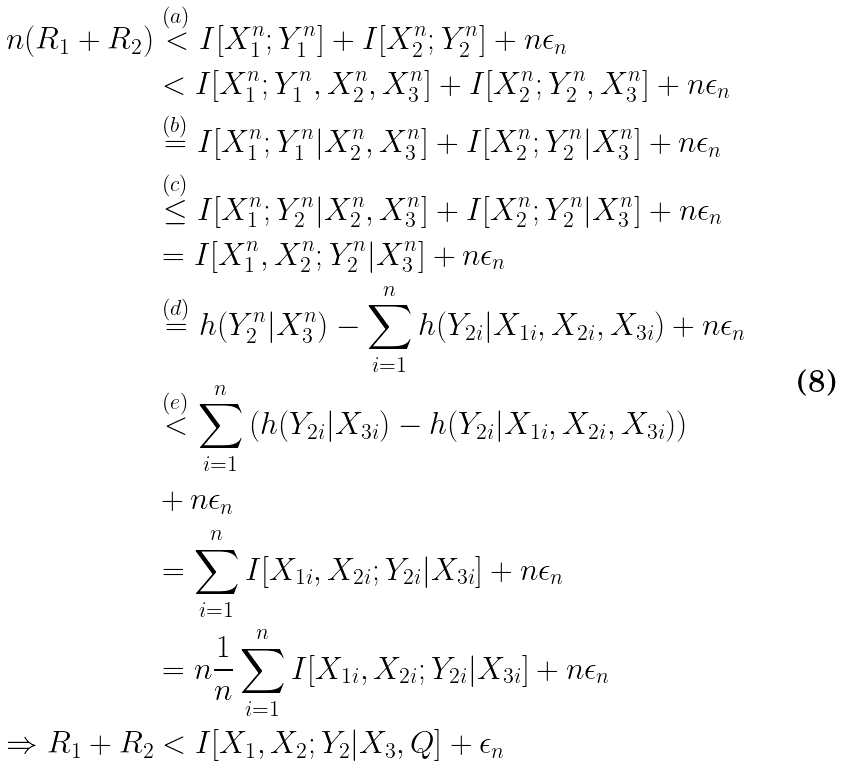Convert formula to latex. <formula><loc_0><loc_0><loc_500><loc_500>n ( R _ { 1 } + R _ { 2 } ) & \stackrel { ( a ) } { < } I [ X _ { 1 } ^ { n } ; Y _ { 1 } ^ { n } ] + I [ X _ { 2 } ^ { n } ; Y _ { 2 } ^ { n } ] + n \epsilon _ { n } \\ & < I [ X _ { 1 } ^ { n } ; Y _ { 1 } ^ { n } , X _ { 2 } ^ { n } , X _ { 3 } ^ { n } ] + I [ X _ { 2 } ^ { n } ; Y _ { 2 } ^ { n } , X _ { 3 } ^ { n } ] + n \epsilon _ { n } \\ & \stackrel { ( b ) } { = } I [ X _ { 1 } ^ { n } ; Y _ { 1 } ^ { n } | X _ { 2 } ^ { n } , X _ { 3 } ^ { n } ] + I [ X _ { 2 } ^ { n } ; Y _ { 2 } ^ { n } | X _ { 3 } ^ { n } ] + n \epsilon _ { n } \\ & \stackrel { ( c ) } { \leq } I [ X _ { 1 } ^ { n } ; Y _ { 2 } ^ { n } | X _ { 2 } ^ { n } , X _ { 3 } ^ { n } ] + I [ X _ { 2 } ^ { n } ; Y _ { 2 } ^ { n } | X _ { 3 } ^ { n } ] + n \epsilon _ { n } \\ & = I [ X _ { 1 } ^ { n } , X _ { 2 } ^ { n } ; Y _ { 2 } ^ { n } | X _ { 3 } ^ { n } ] + n \epsilon _ { n } \\ & \stackrel { ( d ) } { = } h ( Y _ { 2 } ^ { n } | X _ { 3 } ^ { n } ) - \sum _ { i = 1 } ^ { n } h ( Y _ { 2 i } | X _ { 1 i } , X _ { 2 i } , X _ { 3 i } ) + n \epsilon _ { n } \\ & \stackrel { ( e ) } { < } \sum _ { i = 1 } ^ { n } \left ( h ( Y _ { 2 i } | X _ { 3 i } ) - h ( Y _ { 2 i } | X _ { 1 i } , X _ { 2 i } , X _ { 3 i } ) \right ) \\ & + n \epsilon _ { n } \\ & = \sum _ { i = 1 } ^ { n } I [ X _ { 1 i } , X _ { 2 i } ; Y _ { 2 i } | X _ { 3 i } ] + n \epsilon _ { n } \\ & = n \frac { 1 } { n } \sum _ { i = 1 } ^ { n } I [ X _ { 1 i } , X _ { 2 i } ; Y _ { 2 i } | X _ { 3 i } ] + n \epsilon _ { n } \\ \Rightarrow R _ { 1 } + R _ { 2 } & < I [ X _ { 1 } , X _ { 2 } ; Y _ { 2 } | X _ { 3 } , Q ] + \epsilon _ { n }</formula> 